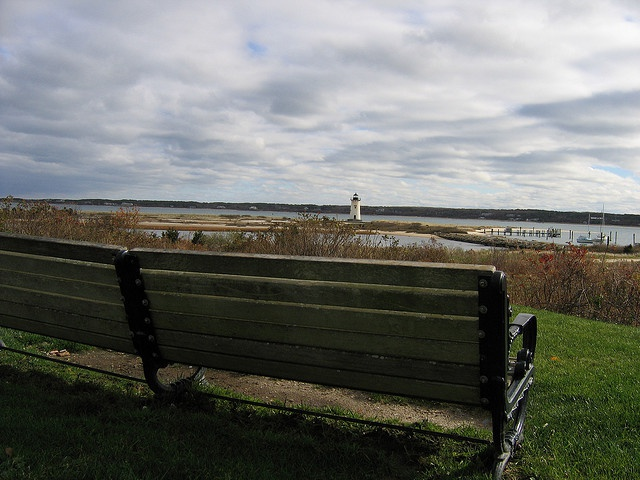Describe the objects in this image and their specific colors. I can see bench in darkgray, black, darkgreen, and gray tones, bench in darkgray, black, darkgreen, and gray tones, and boat in darkgray, gray, and black tones in this image. 